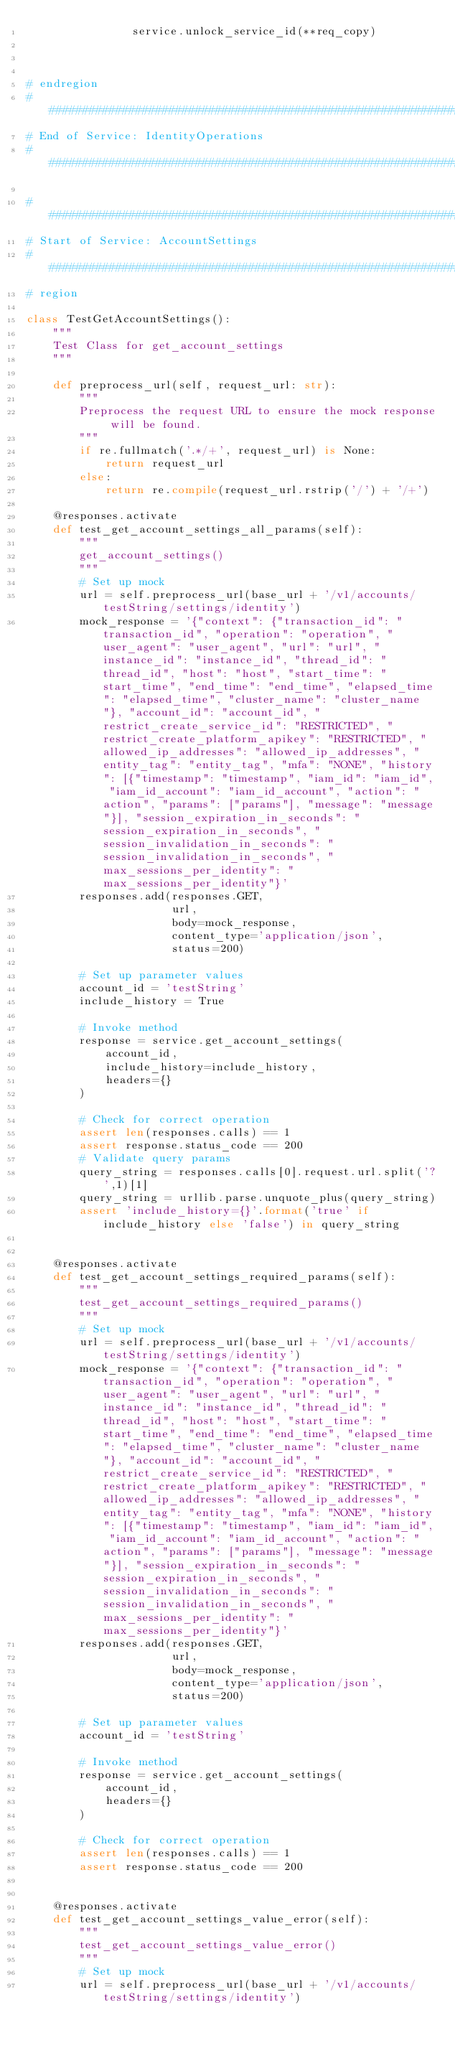Convert code to text. <code><loc_0><loc_0><loc_500><loc_500><_Python_>                service.unlock_service_id(**req_copy)



# endregion
##############################################################################
# End of Service: IdentityOperations
##############################################################################

##############################################################################
# Start of Service: AccountSettings
##############################################################################
# region

class TestGetAccountSettings():
    """
    Test Class for get_account_settings
    """

    def preprocess_url(self, request_url: str):
        """
        Preprocess the request URL to ensure the mock response will be found.
        """
        if re.fullmatch('.*/+', request_url) is None:
            return request_url
        else:
            return re.compile(request_url.rstrip('/') + '/+')

    @responses.activate
    def test_get_account_settings_all_params(self):
        """
        get_account_settings()
        """
        # Set up mock
        url = self.preprocess_url(base_url + '/v1/accounts/testString/settings/identity')
        mock_response = '{"context": {"transaction_id": "transaction_id", "operation": "operation", "user_agent": "user_agent", "url": "url", "instance_id": "instance_id", "thread_id": "thread_id", "host": "host", "start_time": "start_time", "end_time": "end_time", "elapsed_time": "elapsed_time", "cluster_name": "cluster_name"}, "account_id": "account_id", "restrict_create_service_id": "RESTRICTED", "restrict_create_platform_apikey": "RESTRICTED", "allowed_ip_addresses": "allowed_ip_addresses", "entity_tag": "entity_tag", "mfa": "NONE", "history": [{"timestamp": "timestamp", "iam_id": "iam_id", "iam_id_account": "iam_id_account", "action": "action", "params": ["params"], "message": "message"}], "session_expiration_in_seconds": "session_expiration_in_seconds", "session_invalidation_in_seconds": "session_invalidation_in_seconds", "max_sessions_per_identity": "max_sessions_per_identity"}'
        responses.add(responses.GET,
                      url,
                      body=mock_response,
                      content_type='application/json',
                      status=200)

        # Set up parameter values
        account_id = 'testString'
        include_history = True

        # Invoke method
        response = service.get_account_settings(
            account_id,
            include_history=include_history,
            headers={}
        )

        # Check for correct operation
        assert len(responses.calls) == 1
        assert response.status_code == 200
        # Validate query params
        query_string = responses.calls[0].request.url.split('?',1)[1]
        query_string = urllib.parse.unquote_plus(query_string)
        assert 'include_history={}'.format('true' if include_history else 'false') in query_string


    @responses.activate
    def test_get_account_settings_required_params(self):
        """
        test_get_account_settings_required_params()
        """
        # Set up mock
        url = self.preprocess_url(base_url + '/v1/accounts/testString/settings/identity')
        mock_response = '{"context": {"transaction_id": "transaction_id", "operation": "operation", "user_agent": "user_agent", "url": "url", "instance_id": "instance_id", "thread_id": "thread_id", "host": "host", "start_time": "start_time", "end_time": "end_time", "elapsed_time": "elapsed_time", "cluster_name": "cluster_name"}, "account_id": "account_id", "restrict_create_service_id": "RESTRICTED", "restrict_create_platform_apikey": "RESTRICTED", "allowed_ip_addresses": "allowed_ip_addresses", "entity_tag": "entity_tag", "mfa": "NONE", "history": [{"timestamp": "timestamp", "iam_id": "iam_id", "iam_id_account": "iam_id_account", "action": "action", "params": ["params"], "message": "message"}], "session_expiration_in_seconds": "session_expiration_in_seconds", "session_invalidation_in_seconds": "session_invalidation_in_seconds", "max_sessions_per_identity": "max_sessions_per_identity"}'
        responses.add(responses.GET,
                      url,
                      body=mock_response,
                      content_type='application/json',
                      status=200)

        # Set up parameter values
        account_id = 'testString'

        # Invoke method
        response = service.get_account_settings(
            account_id,
            headers={}
        )

        # Check for correct operation
        assert len(responses.calls) == 1
        assert response.status_code == 200


    @responses.activate
    def test_get_account_settings_value_error(self):
        """
        test_get_account_settings_value_error()
        """
        # Set up mock
        url = self.preprocess_url(base_url + '/v1/accounts/testString/settings/identity')</code> 